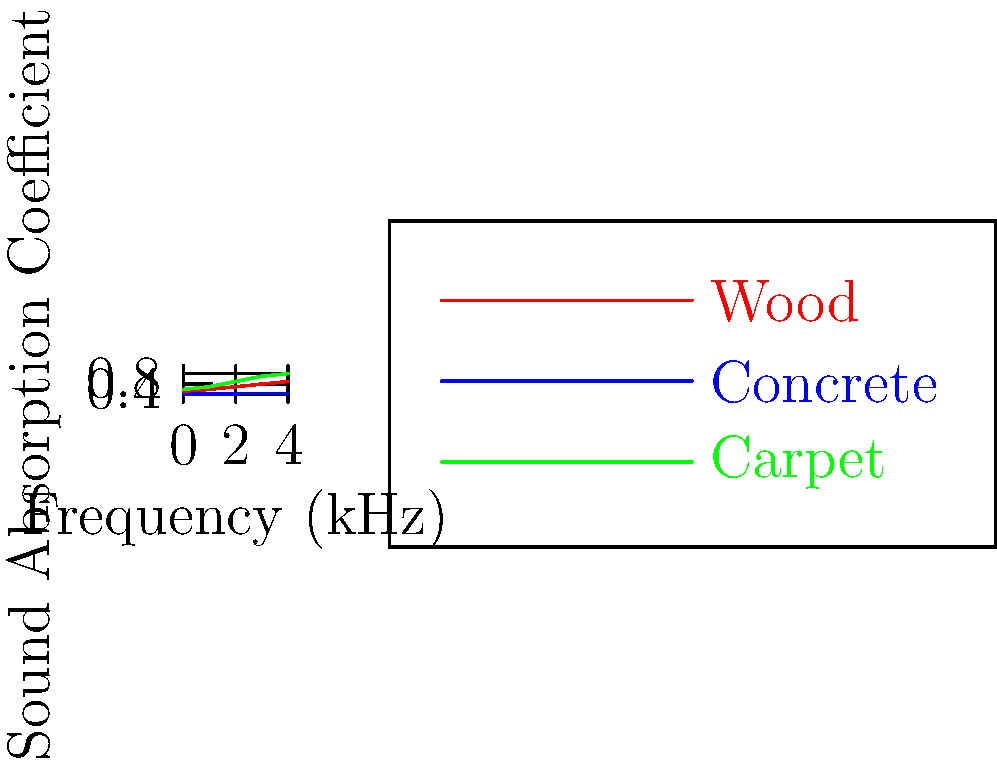As a saxophonist who often performs in various venues, you're interested in the acoustic properties of different materials used in concert halls. Based on the graph showing sound absorption coefficients for wood, concrete, and carpet across different frequencies, which material would be most effective in reducing echo and reverberation in a jazz club setting, particularly for the typical frequency range of a saxophone (approximately 100 Hz to 700 Hz)? To answer this question, let's analyze the graph and consider the properties of each material:

1. The x-axis represents frequency in kHz, and the y-axis represents the sound absorption coefficient.
2. A higher absorption coefficient indicates better sound absorption (less reflection).
3. The typical frequency range of a saxophone (100 Hz to 700 Hz) corresponds roughly to the first two data points on the graph (0-1 kHz).
4. Analyzing each material:
   a) Wood: Absorption coefficient increases from about 0.1 to 0.2 in the relevant range.
   b) Concrete: Very low absorption coefficient, increasing from about 0.01 to 0.02.
   c) Carpet: Highest absorption coefficient, increasing from about 0.2 to 0.3.
5. For reducing echo and reverberation, we want the material with the highest absorption coefficient.
6. Carpet clearly has the highest absorption coefficient in the relevant frequency range.

Therefore, carpet would be most effective in reducing echo and reverberation for saxophone performances in a jazz club setting.
Answer: Carpet 